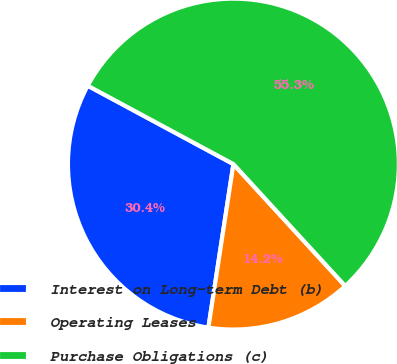<chart> <loc_0><loc_0><loc_500><loc_500><pie_chart><fcel>Interest on Long-term Debt (b)<fcel>Operating Leases<fcel>Purchase Obligations (c)<nl><fcel>30.44%<fcel>14.23%<fcel>55.33%<nl></chart> 